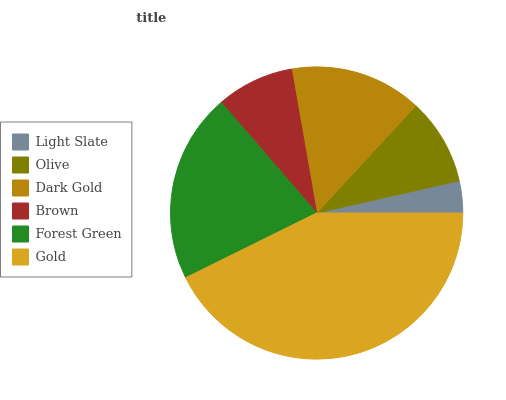Is Light Slate the minimum?
Answer yes or no. Yes. Is Gold the maximum?
Answer yes or no. Yes. Is Olive the minimum?
Answer yes or no. No. Is Olive the maximum?
Answer yes or no. No. Is Olive greater than Light Slate?
Answer yes or no. Yes. Is Light Slate less than Olive?
Answer yes or no. Yes. Is Light Slate greater than Olive?
Answer yes or no. No. Is Olive less than Light Slate?
Answer yes or no. No. Is Dark Gold the high median?
Answer yes or no. Yes. Is Olive the low median?
Answer yes or no. Yes. Is Gold the high median?
Answer yes or no. No. Is Gold the low median?
Answer yes or no. No. 